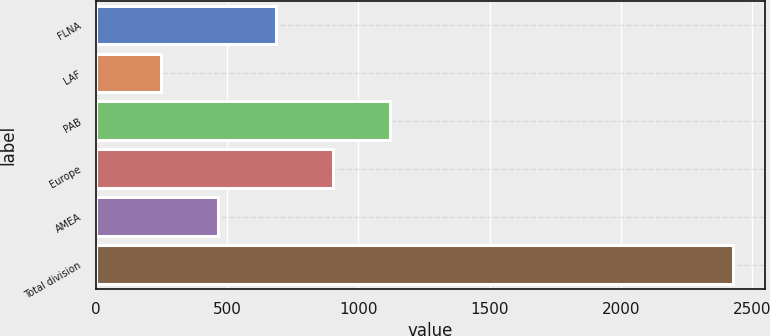<chart> <loc_0><loc_0><loc_500><loc_500><bar_chart><fcel>FLNA<fcel>LAF<fcel>PAB<fcel>Europe<fcel>AMEA<fcel>Total division<nl><fcel>684<fcel>248<fcel>1120<fcel>902<fcel>466<fcel>2428<nl></chart> 